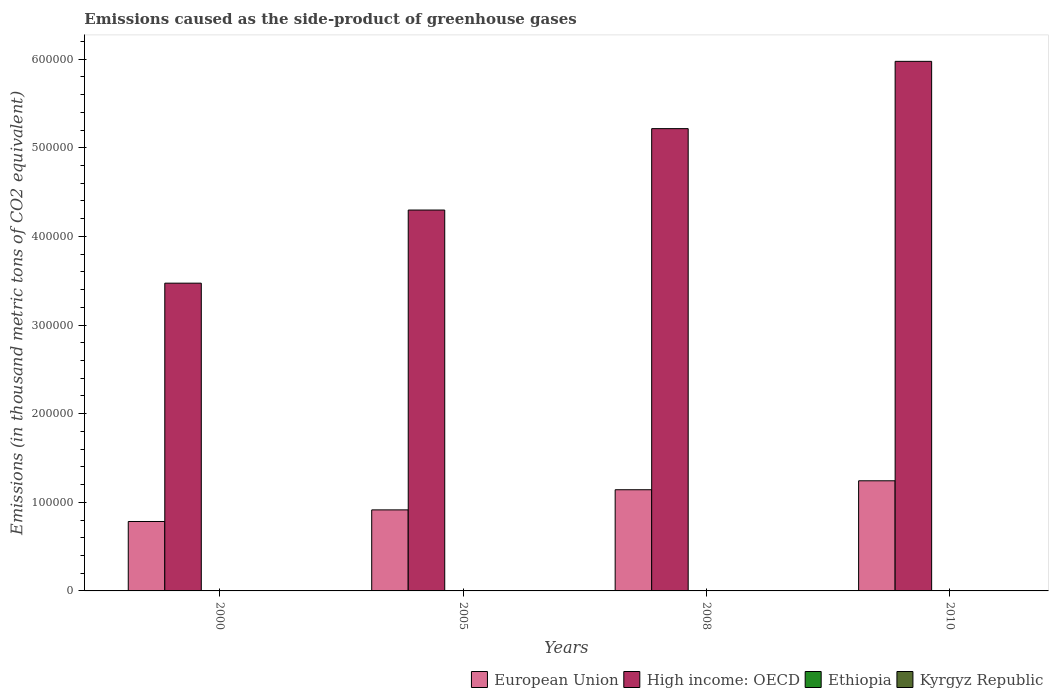How many groups of bars are there?
Ensure brevity in your answer.  4. Are the number of bars per tick equal to the number of legend labels?
Offer a terse response. Yes. How many bars are there on the 4th tick from the left?
Provide a short and direct response. 4. What is the emissions caused as the side-product of greenhouse gases in High income: OECD in 2008?
Your answer should be compact. 5.22e+05. Across all years, what is the maximum emissions caused as the side-product of greenhouse gases in High income: OECD?
Keep it short and to the point. 5.97e+05. Across all years, what is the minimum emissions caused as the side-product of greenhouse gases in High income: OECD?
Your response must be concise. 3.47e+05. In which year was the emissions caused as the side-product of greenhouse gases in High income: OECD maximum?
Provide a succinct answer. 2010. In which year was the emissions caused as the side-product of greenhouse gases in High income: OECD minimum?
Your answer should be very brief. 2000. What is the total emissions caused as the side-product of greenhouse gases in Kyrgyz Republic in the graph?
Your answer should be very brief. 108.7. What is the difference between the emissions caused as the side-product of greenhouse gases in High income: OECD in 2000 and that in 2005?
Your answer should be compact. -8.25e+04. What is the difference between the emissions caused as the side-product of greenhouse gases in Kyrgyz Republic in 2000 and the emissions caused as the side-product of greenhouse gases in European Union in 2010?
Your answer should be very brief. -1.24e+05. What is the average emissions caused as the side-product of greenhouse gases in European Union per year?
Provide a short and direct response. 1.02e+05. In the year 2000, what is the difference between the emissions caused as the side-product of greenhouse gases in European Union and emissions caused as the side-product of greenhouse gases in Kyrgyz Republic?
Give a very brief answer. 7.83e+04. What is the ratio of the emissions caused as the side-product of greenhouse gases in Ethiopia in 2005 to that in 2008?
Give a very brief answer. 0.77. Is the emissions caused as the side-product of greenhouse gases in Ethiopia in 2000 less than that in 2005?
Offer a terse response. Yes. What is the difference between the highest and the second highest emissions caused as the side-product of greenhouse gases in Kyrgyz Republic?
Ensure brevity in your answer.  7.2. What is the difference between the highest and the lowest emissions caused as the side-product of greenhouse gases in Kyrgyz Republic?
Give a very brief answer. 34.1. In how many years, is the emissions caused as the side-product of greenhouse gases in Ethiopia greater than the average emissions caused as the side-product of greenhouse gases in Ethiopia taken over all years?
Your response must be concise. 2. Is it the case that in every year, the sum of the emissions caused as the side-product of greenhouse gases in Kyrgyz Republic and emissions caused as the side-product of greenhouse gases in High income: OECD is greater than the sum of emissions caused as the side-product of greenhouse gases in Ethiopia and emissions caused as the side-product of greenhouse gases in European Union?
Offer a terse response. Yes. What does the 3rd bar from the left in 2008 represents?
Keep it short and to the point. Ethiopia. Are all the bars in the graph horizontal?
Offer a terse response. No. What is the difference between two consecutive major ticks on the Y-axis?
Your answer should be very brief. 1.00e+05. Does the graph contain any zero values?
Ensure brevity in your answer.  No. How are the legend labels stacked?
Offer a terse response. Horizontal. What is the title of the graph?
Your answer should be compact. Emissions caused as the side-product of greenhouse gases. Does "Upper middle income" appear as one of the legend labels in the graph?
Keep it short and to the point. No. What is the label or title of the Y-axis?
Ensure brevity in your answer.  Emissions (in thousand metric tons of CO2 equivalent). What is the Emissions (in thousand metric tons of CO2 equivalent) of European Union in 2000?
Keep it short and to the point. 7.83e+04. What is the Emissions (in thousand metric tons of CO2 equivalent) in High income: OECD in 2000?
Your answer should be compact. 3.47e+05. What is the Emissions (in thousand metric tons of CO2 equivalent) in Ethiopia in 2000?
Give a very brief answer. 3.6. What is the Emissions (in thousand metric tons of CO2 equivalent) in Kyrgyz Republic in 2000?
Provide a short and direct response. 7.9. What is the Emissions (in thousand metric tons of CO2 equivalent) of European Union in 2005?
Make the answer very short. 9.14e+04. What is the Emissions (in thousand metric tons of CO2 equivalent) in High income: OECD in 2005?
Your answer should be compact. 4.30e+05. What is the Emissions (in thousand metric tons of CO2 equivalent) in European Union in 2008?
Offer a very short reply. 1.14e+05. What is the Emissions (in thousand metric tons of CO2 equivalent) in High income: OECD in 2008?
Ensure brevity in your answer.  5.22e+05. What is the Emissions (in thousand metric tons of CO2 equivalent) in Kyrgyz Republic in 2008?
Make the answer very short. 34.8. What is the Emissions (in thousand metric tons of CO2 equivalent) in European Union in 2010?
Keep it short and to the point. 1.24e+05. What is the Emissions (in thousand metric tons of CO2 equivalent) in High income: OECD in 2010?
Your answer should be compact. 5.97e+05. What is the Emissions (in thousand metric tons of CO2 equivalent) of Ethiopia in 2010?
Ensure brevity in your answer.  16. What is the Emissions (in thousand metric tons of CO2 equivalent) of Kyrgyz Republic in 2010?
Make the answer very short. 42. Across all years, what is the maximum Emissions (in thousand metric tons of CO2 equivalent) in European Union?
Give a very brief answer. 1.24e+05. Across all years, what is the maximum Emissions (in thousand metric tons of CO2 equivalent) of High income: OECD?
Provide a succinct answer. 5.97e+05. Across all years, what is the maximum Emissions (in thousand metric tons of CO2 equivalent) of Ethiopia?
Your answer should be very brief. 16. Across all years, what is the maximum Emissions (in thousand metric tons of CO2 equivalent) in Kyrgyz Republic?
Ensure brevity in your answer.  42. Across all years, what is the minimum Emissions (in thousand metric tons of CO2 equivalent) in European Union?
Ensure brevity in your answer.  7.83e+04. Across all years, what is the minimum Emissions (in thousand metric tons of CO2 equivalent) in High income: OECD?
Make the answer very short. 3.47e+05. What is the total Emissions (in thousand metric tons of CO2 equivalent) in European Union in the graph?
Offer a terse response. 4.08e+05. What is the total Emissions (in thousand metric tons of CO2 equivalent) of High income: OECD in the graph?
Provide a short and direct response. 1.90e+06. What is the total Emissions (in thousand metric tons of CO2 equivalent) in Ethiopia in the graph?
Your response must be concise. 43.2. What is the total Emissions (in thousand metric tons of CO2 equivalent) in Kyrgyz Republic in the graph?
Provide a succinct answer. 108.7. What is the difference between the Emissions (in thousand metric tons of CO2 equivalent) in European Union in 2000 and that in 2005?
Provide a short and direct response. -1.31e+04. What is the difference between the Emissions (in thousand metric tons of CO2 equivalent) of High income: OECD in 2000 and that in 2005?
Your response must be concise. -8.25e+04. What is the difference between the Emissions (in thousand metric tons of CO2 equivalent) in Kyrgyz Republic in 2000 and that in 2005?
Offer a very short reply. -16.1. What is the difference between the Emissions (in thousand metric tons of CO2 equivalent) in European Union in 2000 and that in 2008?
Your response must be concise. -3.58e+04. What is the difference between the Emissions (in thousand metric tons of CO2 equivalent) in High income: OECD in 2000 and that in 2008?
Keep it short and to the point. -1.74e+05. What is the difference between the Emissions (in thousand metric tons of CO2 equivalent) of Kyrgyz Republic in 2000 and that in 2008?
Your answer should be compact. -26.9. What is the difference between the Emissions (in thousand metric tons of CO2 equivalent) of European Union in 2000 and that in 2010?
Provide a succinct answer. -4.59e+04. What is the difference between the Emissions (in thousand metric tons of CO2 equivalent) in High income: OECD in 2000 and that in 2010?
Your answer should be compact. -2.50e+05. What is the difference between the Emissions (in thousand metric tons of CO2 equivalent) of Kyrgyz Republic in 2000 and that in 2010?
Your answer should be compact. -34.1. What is the difference between the Emissions (in thousand metric tons of CO2 equivalent) in European Union in 2005 and that in 2008?
Your response must be concise. -2.27e+04. What is the difference between the Emissions (in thousand metric tons of CO2 equivalent) of High income: OECD in 2005 and that in 2008?
Give a very brief answer. -9.18e+04. What is the difference between the Emissions (in thousand metric tons of CO2 equivalent) of European Union in 2005 and that in 2010?
Provide a succinct answer. -3.28e+04. What is the difference between the Emissions (in thousand metric tons of CO2 equivalent) of High income: OECD in 2005 and that in 2010?
Your answer should be compact. -1.68e+05. What is the difference between the Emissions (in thousand metric tons of CO2 equivalent) of Kyrgyz Republic in 2005 and that in 2010?
Provide a succinct answer. -18. What is the difference between the Emissions (in thousand metric tons of CO2 equivalent) of European Union in 2008 and that in 2010?
Ensure brevity in your answer.  -1.01e+04. What is the difference between the Emissions (in thousand metric tons of CO2 equivalent) of High income: OECD in 2008 and that in 2010?
Give a very brief answer. -7.59e+04. What is the difference between the Emissions (in thousand metric tons of CO2 equivalent) in Kyrgyz Republic in 2008 and that in 2010?
Your answer should be compact. -7.2. What is the difference between the Emissions (in thousand metric tons of CO2 equivalent) in European Union in 2000 and the Emissions (in thousand metric tons of CO2 equivalent) in High income: OECD in 2005?
Offer a very short reply. -3.51e+05. What is the difference between the Emissions (in thousand metric tons of CO2 equivalent) in European Union in 2000 and the Emissions (in thousand metric tons of CO2 equivalent) in Ethiopia in 2005?
Provide a succinct answer. 7.83e+04. What is the difference between the Emissions (in thousand metric tons of CO2 equivalent) in European Union in 2000 and the Emissions (in thousand metric tons of CO2 equivalent) in Kyrgyz Republic in 2005?
Offer a terse response. 7.83e+04. What is the difference between the Emissions (in thousand metric tons of CO2 equivalent) of High income: OECD in 2000 and the Emissions (in thousand metric tons of CO2 equivalent) of Ethiopia in 2005?
Offer a terse response. 3.47e+05. What is the difference between the Emissions (in thousand metric tons of CO2 equivalent) in High income: OECD in 2000 and the Emissions (in thousand metric tons of CO2 equivalent) in Kyrgyz Republic in 2005?
Ensure brevity in your answer.  3.47e+05. What is the difference between the Emissions (in thousand metric tons of CO2 equivalent) of Ethiopia in 2000 and the Emissions (in thousand metric tons of CO2 equivalent) of Kyrgyz Republic in 2005?
Make the answer very short. -20.4. What is the difference between the Emissions (in thousand metric tons of CO2 equivalent) in European Union in 2000 and the Emissions (in thousand metric tons of CO2 equivalent) in High income: OECD in 2008?
Offer a terse response. -4.43e+05. What is the difference between the Emissions (in thousand metric tons of CO2 equivalent) of European Union in 2000 and the Emissions (in thousand metric tons of CO2 equivalent) of Ethiopia in 2008?
Your answer should be very brief. 7.83e+04. What is the difference between the Emissions (in thousand metric tons of CO2 equivalent) in European Union in 2000 and the Emissions (in thousand metric tons of CO2 equivalent) in Kyrgyz Republic in 2008?
Make the answer very short. 7.83e+04. What is the difference between the Emissions (in thousand metric tons of CO2 equivalent) in High income: OECD in 2000 and the Emissions (in thousand metric tons of CO2 equivalent) in Ethiopia in 2008?
Provide a short and direct response. 3.47e+05. What is the difference between the Emissions (in thousand metric tons of CO2 equivalent) of High income: OECD in 2000 and the Emissions (in thousand metric tons of CO2 equivalent) of Kyrgyz Republic in 2008?
Make the answer very short. 3.47e+05. What is the difference between the Emissions (in thousand metric tons of CO2 equivalent) in Ethiopia in 2000 and the Emissions (in thousand metric tons of CO2 equivalent) in Kyrgyz Republic in 2008?
Your answer should be compact. -31.2. What is the difference between the Emissions (in thousand metric tons of CO2 equivalent) in European Union in 2000 and the Emissions (in thousand metric tons of CO2 equivalent) in High income: OECD in 2010?
Make the answer very short. -5.19e+05. What is the difference between the Emissions (in thousand metric tons of CO2 equivalent) of European Union in 2000 and the Emissions (in thousand metric tons of CO2 equivalent) of Ethiopia in 2010?
Provide a succinct answer. 7.83e+04. What is the difference between the Emissions (in thousand metric tons of CO2 equivalent) in European Union in 2000 and the Emissions (in thousand metric tons of CO2 equivalent) in Kyrgyz Republic in 2010?
Make the answer very short. 7.83e+04. What is the difference between the Emissions (in thousand metric tons of CO2 equivalent) of High income: OECD in 2000 and the Emissions (in thousand metric tons of CO2 equivalent) of Ethiopia in 2010?
Provide a succinct answer. 3.47e+05. What is the difference between the Emissions (in thousand metric tons of CO2 equivalent) of High income: OECD in 2000 and the Emissions (in thousand metric tons of CO2 equivalent) of Kyrgyz Republic in 2010?
Provide a succinct answer. 3.47e+05. What is the difference between the Emissions (in thousand metric tons of CO2 equivalent) of Ethiopia in 2000 and the Emissions (in thousand metric tons of CO2 equivalent) of Kyrgyz Republic in 2010?
Ensure brevity in your answer.  -38.4. What is the difference between the Emissions (in thousand metric tons of CO2 equivalent) in European Union in 2005 and the Emissions (in thousand metric tons of CO2 equivalent) in High income: OECD in 2008?
Make the answer very short. -4.30e+05. What is the difference between the Emissions (in thousand metric tons of CO2 equivalent) in European Union in 2005 and the Emissions (in thousand metric tons of CO2 equivalent) in Ethiopia in 2008?
Provide a short and direct response. 9.14e+04. What is the difference between the Emissions (in thousand metric tons of CO2 equivalent) in European Union in 2005 and the Emissions (in thousand metric tons of CO2 equivalent) in Kyrgyz Republic in 2008?
Give a very brief answer. 9.14e+04. What is the difference between the Emissions (in thousand metric tons of CO2 equivalent) of High income: OECD in 2005 and the Emissions (in thousand metric tons of CO2 equivalent) of Ethiopia in 2008?
Your answer should be very brief. 4.30e+05. What is the difference between the Emissions (in thousand metric tons of CO2 equivalent) of High income: OECD in 2005 and the Emissions (in thousand metric tons of CO2 equivalent) of Kyrgyz Republic in 2008?
Provide a short and direct response. 4.30e+05. What is the difference between the Emissions (in thousand metric tons of CO2 equivalent) in Ethiopia in 2005 and the Emissions (in thousand metric tons of CO2 equivalent) in Kyrgyz Republic in 2008?
Offer a terse response. -24.5. What is the difference between the Emissions (in thousand metric tons of CO2 equivalent) in European Union in 2005 and the Emissions (in thousand metric tons of CO2 equivalent) in High income: OECD in 2010?
Make the answer very short. -5.06e+05. What is the difference between the Emissions (in thousand metric tons of CO2 equivalent) in European Union in 2005 and the Emissions (in thousand metric tons of CO2 equivalent) in Ethiopia in 2010?
Your response must be concise. 9.14e+04. What is the difference between the Emissions (in thousand metric tons of CO2 equivalent) in European Union in 2005 and the Emissions (in thousand metric tons of CO2 equivalent) in Kyrgyz Republic in 2010?
Your answer should be very brief. 9.14e+04. What is the difference between the Emissions (in thousand metric tons of CO2 equivalent) in High income: OECD in 2005 and the Emissions (in thousand metric tons of CO2 equivalent) in Ethiopia in 2010?
Ensure brevity in your answer.  4.30e+05. What is the difference between the Emissions (in thousand metric tons of CO2 equivalent) of High income: OECD in 2005 and the Emissions (in thousand metric tons of CO2 equivalent) of Kyrgyz Republic in 2010?
Your answer should be compact. 4.30e+05. What is the difference between the Emissions (in thousand metric tons of CO2 equivalent) of Ethiopia in 2005 and the Emissions (in thousand metric tons of CO2 equivalent) of Kyrgyz Republic in 2010?
Your answer should be very brief. -31.7. What is the difference between the Emissions (in thousand metric tons of CO2 equivalent) of European Union in 2008 and the Emissions (in thousand metric tons of CO2 equivalent) of High income: OECD in 2010?
Your answer should be very brief. -4.83e+05. What is the difference between the Emissions (in thousand metric tons of CO2 equivalent) of European Union in 2008 and the Emissions (in thousand metric tons of CO2 equivalent) of Ethiopia in 2010?
Keep it short and to the point. 1.14e+05. What is the difference between the Emissions (in thousand metric tons of CO2 equivalent) of European Union in 2008 and the Emissions (in thousand metric tons of CO2 equivalent) of Kyrgyz Republic in 2010?
Keep it short and to the point. 1.14e+05. What is the difference between the Emissions (in thousand metric tons of CO2 equivalent) of High income: OECD in 2008 and the Emissions (in thousand metric tons of CO2 equivalent) of Ethiopia in 2010?
Offer a terse response. 5.22e+05. What is the difference between the Emissions (in thousand metric tons of CO2 equivalent) of High income: OECD in 2008 and the Emissions (in thousand metric tons of CO2 equivalent) of Kyrgyz Republic in 2010?
Provide a short and direct response. 5.22e+05. What is the difference between the Emissions (in thousand metric tons of CO2 equivalent) in Ethiopia in 2008 and the Emissions (in thousand metric tons of CO2 equivalent) in Kyrgyz Republic in 2010?
Offer a very short reply. -28.7. What is the average Emissions (in thousand metric tons of CO2 equivalent) of European Union per year?
Ensure brevity in your answer.  1.02e+05. What is the average Emissions (in thousand metric tons of CO2 equivalent) in High income: OECD per year?
Keep it short and to the point. 4.74e+05. What is the average Emissions (in thousand metric tons of CO2 equivalent) of Ethiopia per year?
Offer a very short reply. 10.8. What is the average Emissions (in thousand metric tons of CO2 equivalent) of Kyrgyz Republic per year?
Offer a terse response. 27.18. In the year 2000, what is the difference between the Emissions (in thousand metric tons of CO2 equivalent) of European Union and Emissions (in thousand metric tons of CO2 equivalent) of High income: OECD?
Your answer should be very brief. -2.69e+05. In the year 2000, what is the difference between the Emissions (in thousand metric tons of CO2 equivalent) of European Union and Emissions (in thousand metric tons of CO2 equivalent) of Ethiopia?
Offer a very short reply. 7.83e+04. In the year 2000, what is the difference between the Emissions (in thousand metric tons of CO2 equivalent) in European Union and Emissions (in thousand metric tons of CO2 equivalent) in Kyrgyz Republic?
Provide a succinct answer. 7.83e+04. In the year 2000, what is the difference between the Emissions (in thousand metric tons of CO2 equivalent) of High income: OECD and Emissions (in thousand metric tons of CO2 equivalent) of Ethiopia?
Your answer should be compact. 3.47e+05. In the year 2000, what is the difference between the Emissions (in thousand metric tons of CO2 equivalent) of High income: OECD and Emissions (in thousand metric tons of CO2 equivalent) of Kyrgyz Republic?
Offer a very short reply. 3.47e+05. In the year 2000, what is the difference between the Emissions (in thousand metric tons of CO2 equivalent) of Ethiopia and Emissions (in thousand metric tons of CO2 equivalent) of Kyrgyz Republic?
Give a very brief answer. -4.3. In the year 2005, what is the difference between the Emissions (in thousand metric tons of CO2 equivalent) in European Union and Emissions (in thousand metric tons of CO2 equivalent) in High income: OECD?
Your response must be concise. -3.38e+05. In the year 2005, what is the difference between the Emissions (in thousand metric tons of CO2 equivalent) in European Union and Emissions (in thousand metric tons of CO2 equivalent) in Ethiopia?
Give a very brief answer. 9.14e+04. In the year 2005, what is the difference between the Emissions (in thousand metric tons of CO2 equivalent) of European Union and Emissions (in thousand metric tons of CO2 equivalent) of Kyrgyz Republic?
Your response must be concise. 9.14e+04. In the year 2005, what is the difference between the Emissions (in thousand metric tons of CO2 equivalent) of High income: OECD and Emissions (in thousand metric tons of CO2 equivalent) of Ethiopia?
Keep it short and to the point. 4.30e+05. In the year 2005, what is the difference between the Emissions (in thousand metric tons of CO2 equivalent) of High income: OECD and Emissions (in thousand metric tons of CO2 equivalent) of Kyrgyz Republic?
Ensure brevity in your answer.  4.30e+05. In the year 2005, what is the difference between the Emissions (in thousand metric tons of CO2 equivalent) in Ethiopia and Emissions (in thousand metric tons of CO2 equivalent) in Kyrgyz Republic?
Offer a very short reply. -13.7. In the year 2008, what is the difference between the Emissions (in thousand metric tons of CO2 equivalent) of European Union and Emissions (in thousand metric tons of CO2 equivalent) of High income: OECD?
Offer a very short reply. -4.07e+05. In the year 2008, what is the difference between the Emissions (in thousand metric tons of CO2 equivalent) in European Union and Emissions (in thousand metric tons of CO2 equivalent) in Ethiopia?
Offer a very short reply. 1.14e+05. In the year 2008, what is the difference between the Emissions (in thousand metric tons of CO2 equivalent) in European Union and Emissions (in thousand metric tons of CO2 equivalent) in Kyrgyz Republic?
Your response must be concise. 1.14e+05. In the year 2008, what is the difference between the Emissions (in thousand metric tons of CO2 equivalent) in High income: OECD and Emissions (in thousand metric tons of CO2 equivalent) in Ethiopia?
Your answer should be very brief. 5.22e+05. In the year 2008, what is the difference between the Emissions (in thousand metric tons of CO2 equivalent) of High income: OECD and Emissions (in thousand metric tons of CO2 equivalent) of Kyrgyz Republic?
Provide a succinct answer. 5.22e+05. In the year 2008, what is the difference between the Emissions (in thousand metric tons of CO2 equivalent) of Ethiopia and Emissions (in thousand metric tons of CO2 equivalent) of Kyrgyz Republic?
Your answer should be compact. -21.5. In the year 2010, what is the difference between the Emissions (in thousand metric tons of CO2 equivalent) of European Union and Emissions (in thousand metric tons of CO2 equivalent) of High income: OECD?
Make the answer very short. -4.73e+05. In the year 2010, what is the difference between the Emissions (in thousand metric tons of CO2 equivalent) of European Union and Emissions (in thousand metric tons of CO2 equivalent) of Ethiopia?
Give a very brief answer. 1.24e+05. In the year 2010, what is the difference between the Emissions (in thousand metric tons of CO2 equivalent) in European Union and Emissions (in thousand metric tons of CO2 equivalent) in Kyrgyz Republic?
Your answer should be very brief. 1.24e+05. In the year 2010, what is the difference between the Emissions (in thousand metric tons of CO2 equivalent) in High income: OECD and Emissions (in thousand metric tons of CO2 equivalent) in Ethiopia?
Your answer should be compact. 5.97e+05. In the year 2010, what is the difference between the Emissions (in thousand metric tons of CO2 equivalent) in High income: OECD and Emissions (in thousand metric tons of CO2 equivalent) in Kyrgyz Republic?
Provide a short and direct response. 5.97e+05. What is the ratio of the Emissions (in thousand metric tons of CO2 equivalent) of European Union in 2000 to that in 2005?
Your response must be concise. 0.86. What is the ratio of the Emissions (in thousand metric tons of CO2 equivalent) of High income: OECD in 2000 to that in 2005?
Offer a terse response. 0.81. What is the ratio of the Emissions (in thousand metric tons of CO2 equivalent) in Ethiopia in 2000 to that in 2005?
Provide a short and direct response. 0.35. What is the ratio of the Emissions (in thousand metric tons of CO2 equivalent) of Kyrgyz Republic in 2000 to that in 2005?
Keep it short and to the point. 0.33. What is the ratio of the Emissions (in thousand metric tons of CO2 equivalent) of European Union in 2000 to that in 2008?
Keep it short and to the point. 0.69. What is the ratio of the Emissions (in thousand metric tons of CO2 equivalent) of High income: OECD in 2000 to that in 2008?
Offer a very short reply. 0.67. What is the ratio of the Emissions (in thousand metric tons of CO2 equivalent) in Ethiopia in 2000 to that in 2008?
Provide a short and direct response. 0.27. What is the ratio of the Emissions (in thousand metric tons of CO2 equivalent) in Kyrgyz Republic in 2000 to that in 2008?
Your answer should be very brief. 0.23. What is the ratio of the Emissions (in thousand metric tons of CO2 equivalent) of European Union in 2000 to that in 2010?
Offer a terse response. 0.63. What is the ratio of the Emissions (in thousand metric tons of CO2 equivalent) in High income: OECD in 2000 to that in 2010?
Ensure brevity in your answer.  0.58. What is the ratio of the Emissions (in thousand metric tons of CO2 equivalent) in Ethiopia in 2000 to that in 2010?
Offer a terse response. 0.23. What is the ratio of the Emissions (in thousand metric tons of CO2 equivalent) in Kyrgyz Republic in 2000 to that in 2010?
Make the answer very short. 0.19. What is the ratio of the Emissions (in thousand metric tons of CO2 equivalent) in European Union in 2005 to that in 2008?
Give a very brief answer. 0.8. What is the ratio of the Emissions (in thousand metric tons of CO2 equivalent) of High income: OECD in 2005 to that in 2008?
Your answer should be very brief. 0.82. What is the ratio of the Emissions (in thousand metric tons of CO2 equivalent) in Ethiopia in 2005 to that in 2008?
Offer a terse response. 0.77. What is the ratio of the Emissions (in thousand metric tons of CO2 equivalent) in Kyrgyz Republic in 2005 to that in 2008?
Offer a very short reply. 0.69. What is the ratio of the Emissions (in thousand metric tons of CO2 equivalent) in European Union in 2005 to that in 2010?
Ensure brevity in your answer.  0.74. What is the ratio of the Emissions (in thousand metric tons of CO2 equivalent) in High income: OECD in 2005 to that in 2010?
Keep it short and to the point. 0.72. What is the ratio of the Emissions (in thousand metric tons of CO2 equivalent) of Ethiopia in 2005 to that in 2010?
Offer a terse response. 0.64. What is the ratio of the Emissions (in thousand metric tons of CO2 equivalent) in Kyrgyz Republic in 2005 to that in 2010?
Give a very brief answer. 0.57. What is the ratio of the Emissions (in thousand metric tons of CO2 equivalent) in European Union in 2008 to that in 2010?
Make the answer very short. 0.92. What is the ratio of the Emissions (in thousand metric tons of CO2 equivalent) in High income: OECD in 2008 to that in 2010?
Offer a terse response. 0.87. What is the ratio of the Emissions (in thousand metric tons of CO2 equivalent) in Ethiopia in 2008 to that in 2010?
Provide a short and direct response. 0.83. What is the ratio of the Emissions (in thousand metric tons of CO2 equivalent) in Kyrgyz Republic in 2008 to that in 2010?
Your answer should be very brief. 0.83. What is the difference between the highest and the second highest Emissions (in thousand metric tons of CO2 equivalent) in European Union?
Provide a short and direct response. 1.01e+04. What is the difference between the highest and the second highest Emissions (in thousand metric tons of CO2 equivalent) in High income: OECD?
Your response must be concise. 7.59e+04. What is the difference between the highest and the second highest Emissions (in thousand metric tons of CO2 equivalent) of Ethiopia?
Ensure brevity in your answer.  2.7. What is the difference between the highest and the second highest Emissions (in thousand metric tons of CO2 equivalent) of Kyrgyz Republic?
Offer a very short reply. 7.2. What is the difference between the highest and the lowest Emissions (in thousand metric tons of CO2 equivalent) of European Union?
Your answer should be very brief. 4.59e+04. What is the difference between the highest and the lowest Emissions (in thousand metric tons of CO2 equivalent) of High income: OECD?
Your response must be concise. 2.50e+05. What is the difference between the highest and the lowest Emissions (in thousand metric tons of CO2 equivalent) in Kyrgyz Republic?
Offer a very short reply. 34.1. 